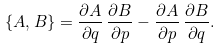<formula> <loc_0><loc_0><loc_500><loc_500>\{ A , B \} = \frac { \partial A } { \partial q } \, \frac { \partial B } { \partial p } - \frac { \partial A } { \partial p } \, \frac { \partial B } { \partial q } .</formula> 